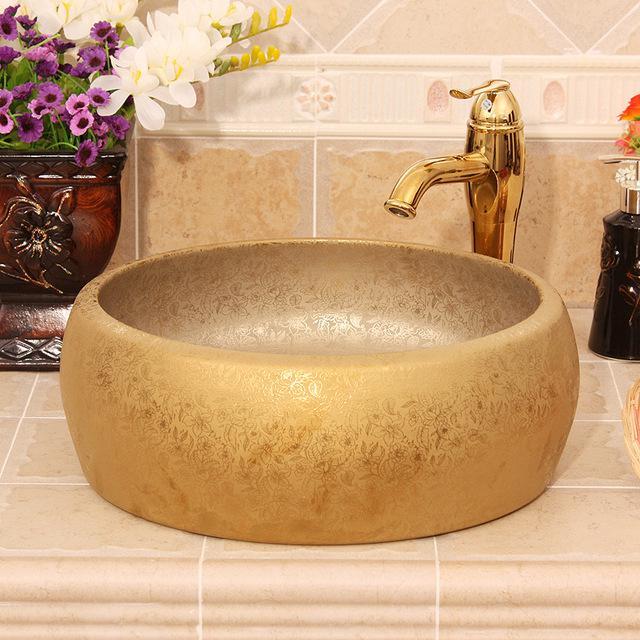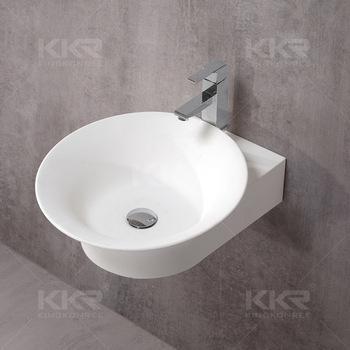The first image is the image on the left, the second image is the image on the right. Examine the images to the left and right. Is the description "Both images in the pair show sinks and one of them is seashell themed." accurate? Answer yes or no. No. The first image is the image on the left, the second image is the image on the right. Analyze the images presented: Is the assertion "The sink in the right image is a bowl sitting on a counter." valid? Answer yes or no. No. 